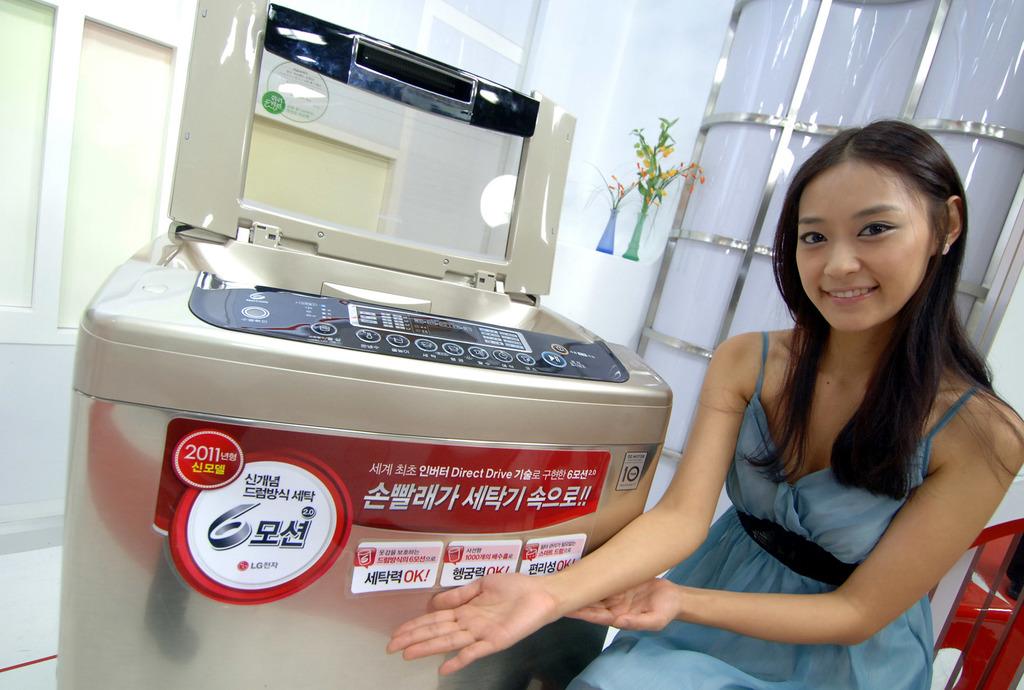What year is listed in the red circle on the label?
Your answer should be very brief. 2011. 